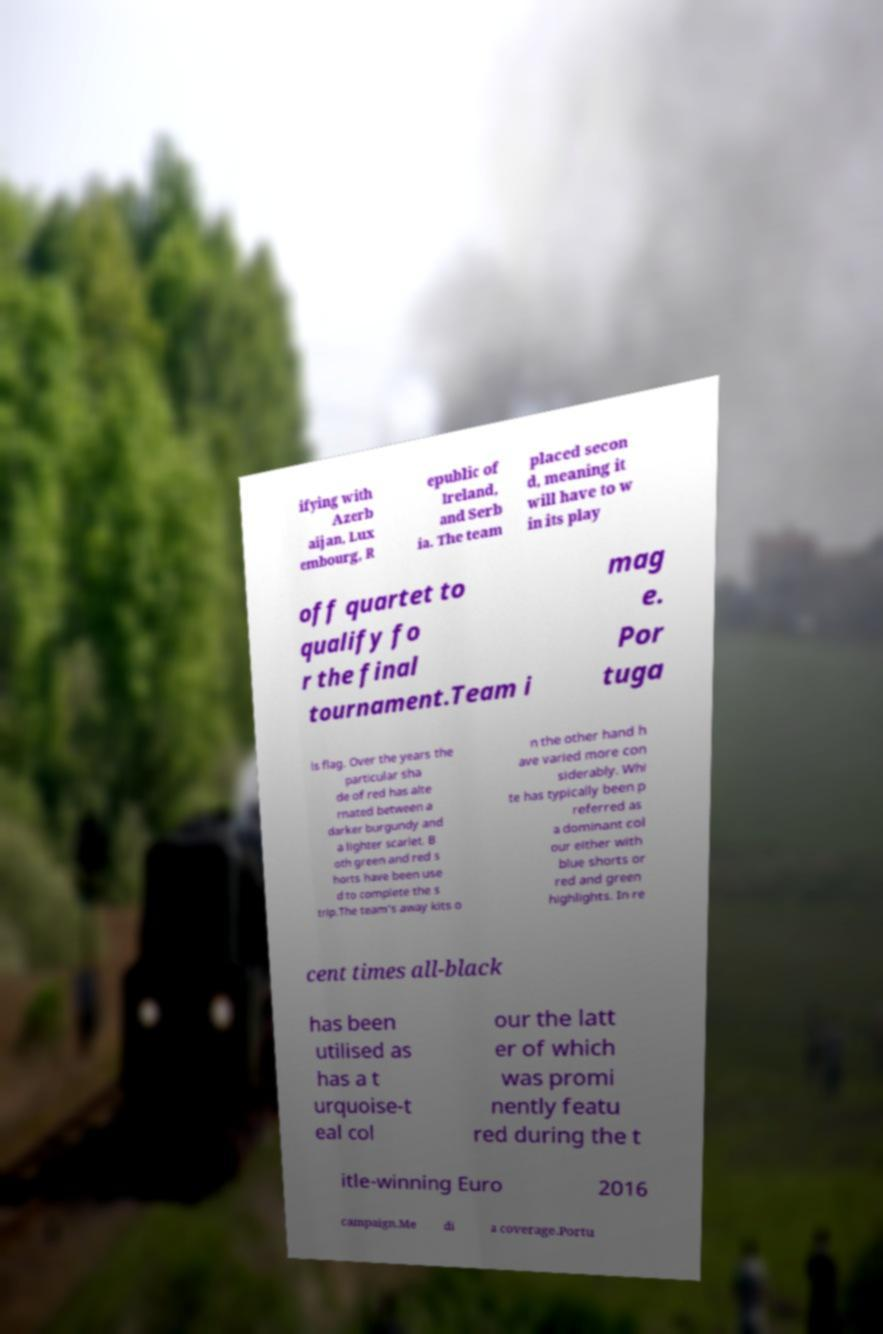Please read and relay the text visible in this image. What does it say? ifying with Azerb aijan, Lux embourg, R epublic of Ireland, and Serb ia. The team placed secon d, meaning it will have to w in its play off quartet to qualify fo r the final tournament.Team i mag e. Por tuga ls flag. Over the years the particular sha de of red has alte rnated between a darker burgundy and a lighter scarlet. B oth green and red s horts have been use d to complete the s trip.The team's away kits o n the other hand h ave varied more con siderably. Whi te has typically been p referred as a dominant col our either with blue shorts or red and green highlights. In re cent times all-black has been utilised as has a t urquoise-t eal col our the latt er of which was promi nently featu red during the t itle-winning Euro 2016 campaign.Me di a coverage.Portu 